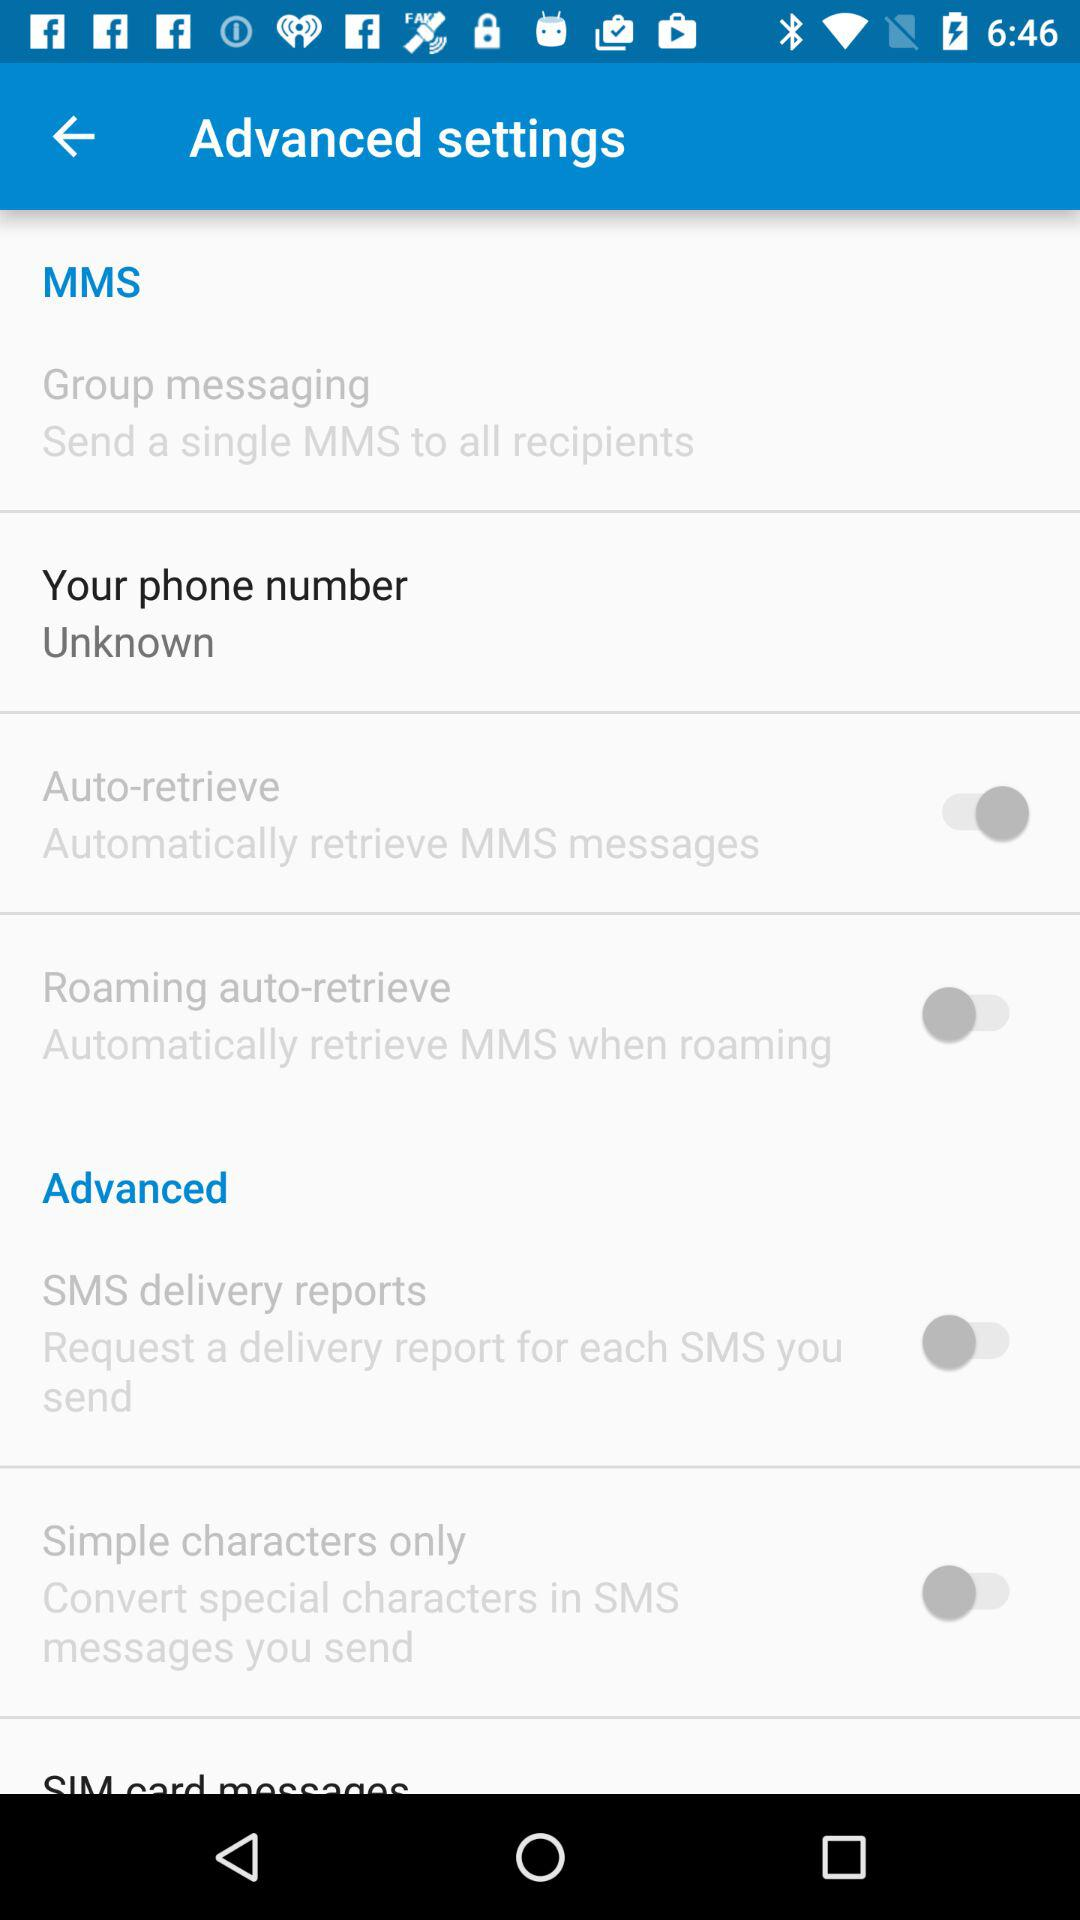What is the phone number? The phone number is unknown. 